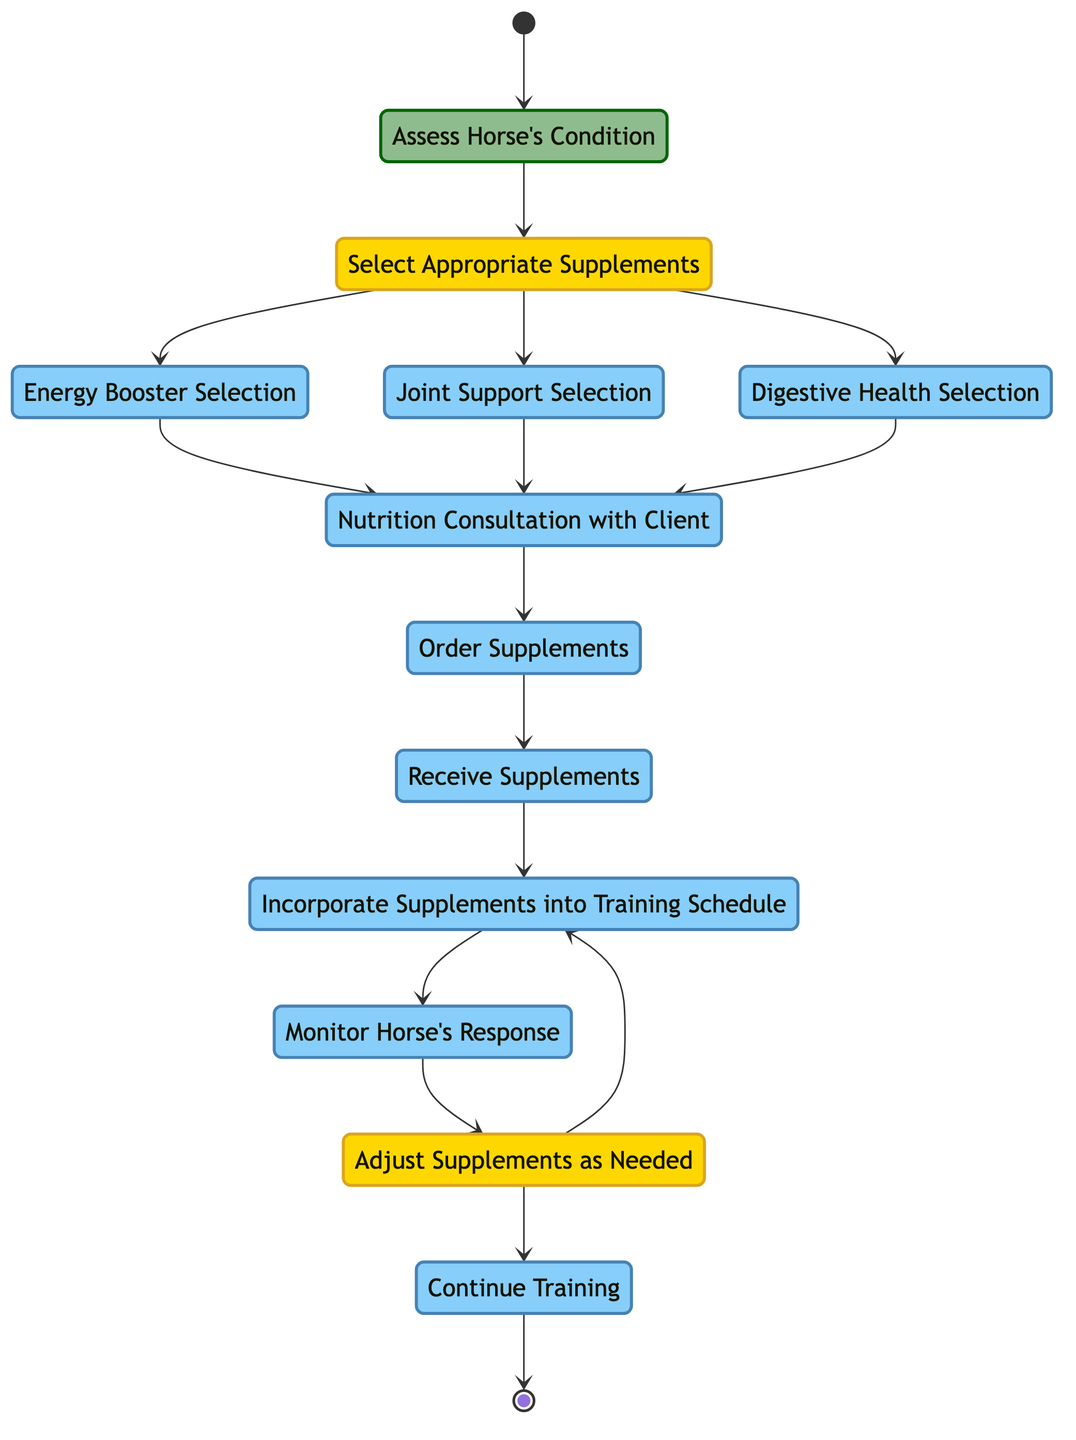What is the starting point of the training session preparation? The starting point, indicated by the initial node, is "Start."
Answer: Start How many decision nodes are present in the diagram? There are two decision nodes: "Select Appropriate Supplements" and "Adjust Supplements as Needed."
Answer: 2 What action follows the "Receive Supplements" node? The action that follows "Receive Supplements" is "Incorporate Supplements into Training Schedule."
Answer: Incorporate Supplements into Training Schedule What type of action is "Nutrition Consultation with Client"? "Nutrition Consultation with Client" is categorized as an action node.
Answer: action How do you progress from "Monitor Horse's Response"? From "Monitor Horse's Response," you can either go to "Adjust Supplements as Needed" or "Continue Training." This indicates a decision that must be made based on the monitoring results.
Answer: Adjust Supplements as Needed or Continue Training What happens if the selected supplements need adjustment? If adjustments are needed, the flow returns to "Incorporate Supplements into Training Schedule" before continuing training, as indicated by the loop in the diagram.
Answer: Incorporate Supplements into Training Schedule What is the last action before reaching the end node? The last action before reaching the end node is "Continue Training."
Answer: Continue Training In case of needing to adjust supplements, which action would repeat? If adjustments are needed, the action that would repeat is "Incorporate Supplements into Training Schedule."
Answer: Incorporate Supplements into Training Schedule How many actions are listed in the diagram? There are a total of eight action nodes listed: "Assess Horse's Condition," "Energy Booster Selection," "Joint Support Selection," "Digestive Health Selection," "Nutrition Consultation with Client," "Order Supplements," "Receive Supplements," and "Incorporate Supplements into Training Schedule."
Answer: 8 What is the endpoint of the training session preparation process? The endpoint of the process is represented by the "End" node.
Answer: End 